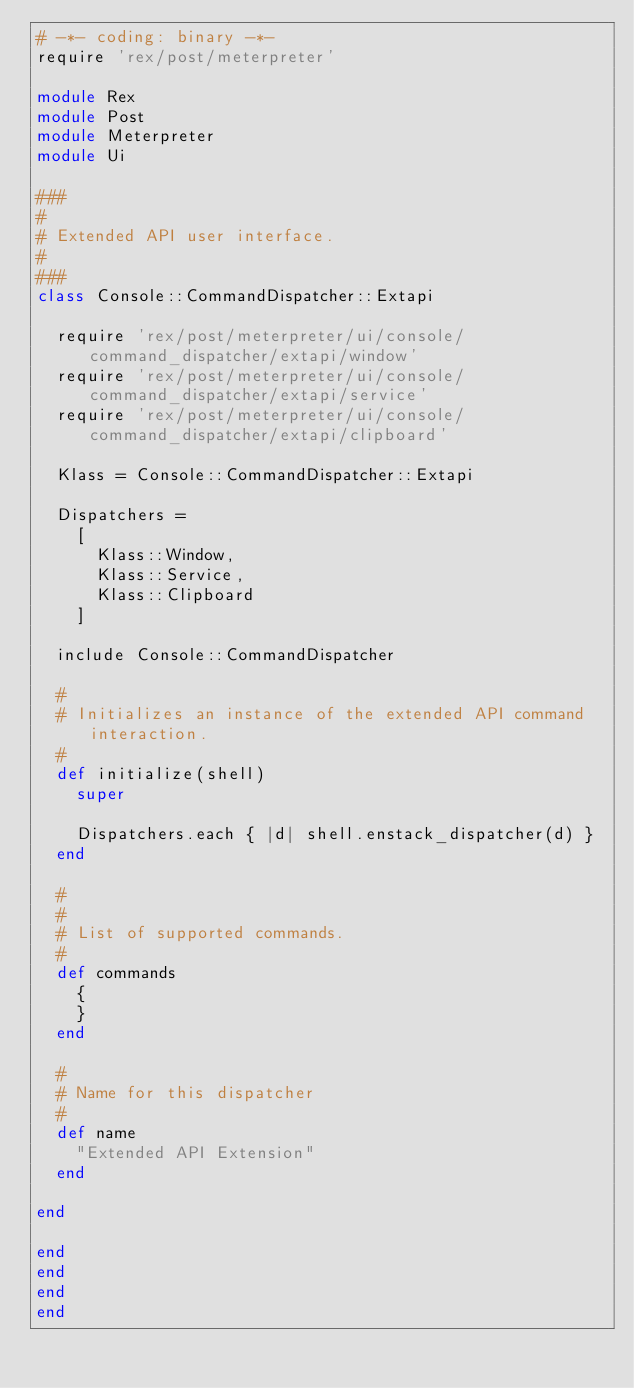Convert code to text. <code><loc_0><loc_0><loc_500><loc_500><_Ruby_># -*- coding: binary -*-
require 'rex/post/meterpreter'

module Rex
module Post
module Meterpreter
module Ui

###
#
# Extended API user interface.
#
###
class Console::CommandDispatcher::Extapi

  require 'rex/post/meterpreter/ui/console/command_dispatcher/extapi/window'
  require 'rex/post/meterpreter/ui/console/command_dispatcher/extapi/service'
  require 'rex/post/meterpreter/ui/console/command_dispatcher/extapi/clipboard'

  Klass = Console::CommandDispatcher::Extapi

  Dispatchers =
    [
      Klass::Window,
      Klass::Service,
      Klass::Clipboard
    ]

  include Console::CommandDispatcher

  #
  # Initializes an instance of the extended API command interaction.
  #
  def initialize(shell)
    super

    Dispatchers.each { |d| shell.enstack_dispatcher(d) }
  end

  #
  #
  # List of supported commands.
  #
  def commands
    {
    }
  end

  #
  # Name for this dispatcher
  #
  def name
    "Extended API Extension"
  end

end

end
end
end
end
</code> 